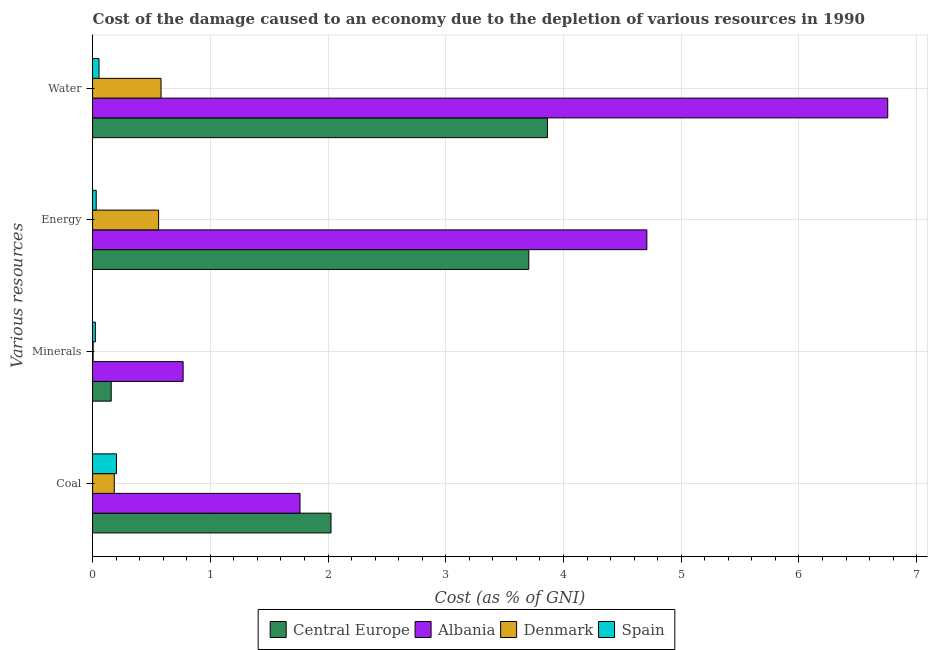How many groups of bars are there?
Give a very brief answer. 4. Are the number of bars per tick equal to the number of legend labels?
Offer a very short reply. Yes. Are the number of bars on each tick of the Y-axis equal?
Give a very brief answer. Yes. How many bars are there on the 3rd tick from the top?
Give a very brief answer. 4. How many bars are there on the 2nd tick from the bottom?
Make the answer very short. 4. What is the label of the 2nd group of bars from the top?
Offer a very short reply. Energy. What is the cost of damage due to depletion of minerals in Denmark?
Offer a very short reply. 0. Across all countries, what is the maximum cost of damage due to depletion of water?
Provide a succinct answer. 6.75. Across all countries, what is the minimum cost of damage due to depletion of energy?
Ensure brevity in your answer.  0.03. In which country was the cost of damage due to depletion of energy maximum?
Make the answer very short. Albania. In which country was the cost of damage due to depletion of coal minimum?
Offer a very short reply. Denmark. What is the total cost of damage due to depletion of water in the graph?
Your answer should be compact. 11.25. What is the difference between the cost of damage due to depletion of water in Spain and that in Denmark?
Provide a short and direct response. -0.53. What is the difference between the cost of damage due to depletion of coal in Central Europe and the cost of damage due to depletion of water in Denmark?
Ensure brevity in your answer.  1.44. What is the average cost of damage due to depletion of coal per country?
Keep it short and to the point. 1.04. What is the difference between the cost of damage due to depletion of coal and cost of damage due to depletion of minerals in Albania?
Provide a succinct answer. 0.99. What is the ratio of the cost of damage due to depletion of water in Spain to that in Denmark?
Provide a succinct answer. 0.09. Is the difference between the cost of damage due to depletion of minerals in Spain and Denmark greater than the difference between the cost of damage due to depletion of water in Spain and Denmark?
Provide a succinct answer. Yes. What is the difference between the highest and the second highest cost of damage due to depletion of water?
Your answer should be compact. 2.89. What is the difference between the highest and the lowest cost of damage due to depletion of water?
Your response must be concise. 6.7. In how many countries, is the cost of damage due to depletion of minerals greater than the average cost of damage due to depletion of minerals taken over all countries?
Your answer should be very brief. 1. What does the 4th bar from the top in Coal represents?
Provide a succinct answer. Central Europe. Is it the case that in every country, the sum of the cost of damage due to depletion of coal and cost of damage due to depletion of minerals is greater than the cost of damage due to depletion of energy?
Ensure brevity in your answer.  No. How many bars are there?
Give a very brief answer. 16. Are all the bars in the graph horizontal?
Your answer should be very brief. Yes. How many countries are there in the graph?
Give a very brief answer. 4. What is the difference between two consecutive major ticks on the X-axis?
Your response must be concise. 1. Are the values on the major ticks of X-axis written in scientific E-notation?
Your answer should be very brief. No. Does the graph contain any zero values?
Your response must be concise. No. Does the graph contain grids?
Give a very brief answer. Yes. How many legend labels are there?
Offer a terse response. 4. How are the legend labels stacked?
Offer a terse response. Horizontal. What is the title of the graph?
Your answer should be compact. Cost of the damage caused to an economy due to the depletion of various resources in 1990 . Does "Latvia" appear as one of the legend labels in the graph?
Ensure brevity in your answer.  No. What is the label or title of the X-axis?
Ensure brevity in your answer.  Cost (as % of GNI). What is the label or title of the Y-axis?
Keep it short and to the point. Various resources. What is the Cost (as % of GNI) in Central Europe in Coal?
Your response must be concise. 2.03. What is the Cost (as % of GNI) of Albania in Coal?
Ensure brevity in your answer.  1.76. What is the Cost (as % of GNI) of Denmark in Coal?
Give a very brief answer. 0.18. What is the Cost (as % of GNI) in Spain in Coal?
Your response must be concise. 0.2. What is the Cost (as % of GNI) of Central Europe in Minerals?
Your response must be concise. 0.16. What is the Cost (as % of GNI) of Albania in Minerals?
Provide a short and direct response. 0.77. What is the Cost (as % of GNI) of Denmark in Minerals?
Provide a short and direct response. 0. What is the Cost (as % of GNI) of Spain in Minerals?
Provide a short and direct response. 0.02. What is the Cost (as % of GNI) in Central Europe in Energy?
Provide a short and direct response. 3.71. What is the Cost (as % of GNI) in Albania in Energy?
Ensure brevity in your answer.  4.71. What is the Cost (as % of GNI) in Denmark in Energy?
Make the answer very short. 0.56. What is the Cost (as % of GNI) in Spain in Energy?
Your answer should be compact. 0.03. What is the Cost (as % of GNI) of Central Europe in Water?
Provide a succinct answer. 3.86. What is the Cost (as % of GNI) of Albania in Water?
Offer a very short reply. 6.75. What is the Cost (as % of GNI) of Denmark in Water?
Keep it short and to the point. 0.58. What is the Cost (as % of GNI) of Spain in Water?
Your answer should be very brief. 0.05. Across all Various resources, what is the maximum Cost (as % of GNI) of Central Europe?
Keep it short and to the point. 3.86. Across all Various resources, what is the maximum Cost (as % of GNI) of Albania?
Offer a terse response. 6.75. Across all Various resources, what is the maximum Cost (as % of GNI) of Denmark?
Provide a succinct answer. 0.58. Across all Various resources, what is the maximum Cost (as % of GNI) of Spain?
Give a very brief answer. 0.2. Across all Various resources, what is the minimum Cost (as % of GNI) in Central Europe?
Your answer should be very brief. 0.16. Across all Various resources, what is the minimum Cost (as % of GNI) of Albania?
Make the answer very short. 0.77. Across all Various resources, what is the minimum Cost (as % of GNI) in Denmark?
Provide a short and direct response. 0. Across all Various resources, what is the minimum Cost (as % of GNI) of Spain?
Provide a short and direct response. 0.02. What is the total Cost (as % of GNI) of Central Europe in the graph?
Your answer should be very brief. 9.75. What is the total Cost (as % of GNI) in Albania in the graph?
Provide a short and direct response. 13.99. What is the total Cost (as % of GNI) of Denmark in the graph?
Provide a short and direct response. 1.33. What is the total Cost (as % of GNI) in Spain in the graph?
Provide a short and direct response. 0.31. What is the difference between the Cost (as % of GNI) in Central Europe in Coal and that in Minerals?
Offer a very short reply. 1.87. What is the difference between the Cost (as % of GNI) in Denmark in Coal and that in Minerals?
Your answer should be compact. 0.18. What is the difference between the Cost (as % of GNI) in Spain in Coal and that in Minerals?
Your answer should be very brief. 0.18. What is the difference between the Cost (as % of GNI) in Central Europe in Coal and that in Energy?
Your answer should be very brief. -1.68. What is the difference between the Cost (as % of GNI) of Albania in Coal and that in Energy?
Make the answer very short. -2.95. What is the difference between the Cost (as % of GNI) of Denmark in Coal and that in Energy?
Keep it short and to the point. -0.38. What is the difference between the Cost (as % of GNI) of Spain in Coal and that in Energy?
Keep it short and to the point. 0.17. What is the difference between the Cost (as % of GNI) in Central Europe in Coal and that in Water?
Provide a succinct answer. -1.84. What is the difference between the Cost (as % of GNI) in Albania in Coal and that in Water?
Your response must be concise. -4.99. What is the difference between the Cost (as % of GNI) of Denmark in Coal and that in Water?
Keep it short and to the point. -0.4. What is the difference between the Cost (as % of GNI) of Spain in Coal and that in Water?
Your response must be concise. 0.15. What is the difference between the Cost (as % of GNI) in Central Europe in Minerals and that in Energy?
Your response must be concise. -3.55. What is the difference between the Cost (as % of GNI) in Albania in Minerals and that in Energy?
Provide a succinct answer. -3.94. What is the difference between the Cost (as % of GNI) of Denmark in Minerals and that in Energy?
Your answer should be compact. -0.56. What is the difference between the Cost (as % of GNI) of Spain in Minerals and that in Energy?
Offer a terse response. -0.01. What is the difference between the Cost (as % of GNI) in Central Europe in Minerals and that in Water?
Your answer should be very brief. -3.71. What is the difference between the Cost (as % of GNI) in Albania in Minerals and that in Water?
Your response must be concise. -5.99. What is the difference between the Cost (as % of GNI) in Denmark in Minerals and that in Water?
Offer a terse response. -0.58. What is the difference between the Cost (as % of GNI) of Spain in Minerals and that in Water?
Provide a succinct answer. -0.03. What is the difference between the Cost (as % of GNI) in Central Europe in Energy and that in Water?
Ensure brevity in your answer.  -0.16. What is the difference between the Cost (as % of GNI) in Albania in Energy and that in Water?
Make the answer very short. -2.05. What is the difference between the Cost (as % of GNI) of Denmark in Energy and that in Water?
Your answer should be very brief. -0.02. What is the difference between the Cost (as % of GNI) of Spain in Energy and that in Water?
Offer a very short reply. -0.02. What is the difference between the Cost (as % of GNI) of Central Europe in Coal and the Cost (as % of GNI) of Albania in Minerals?
Your answer should be compact. 1.26. What is the difference between the Cost (as % of GNI) of Central Europe in Coal and the Cost (as % of GNI) of Denmark in Minerals?
Provide a short and direct response. 2.02. What is the difference between the Cost (as % of GNI) in Central Europe in Coal and the Cost (as % of GNI) in Spain in Minerals?
Give a very brief answer. 2. What is the difference between the Cost (as % of GNI) of Albania in Coal and the Cost (as % of GNI) of Denmark in Minerals?
Ensure brevity in your answer.  1.76. What is the difference between the Cost (as % of GNI) of Albania in Coal and the Cost (as % of GNI) of Spain in Minerals?
Offer a terse response. 1.74. What is the difference between the Cost (as % of GNI) of Denmark in Coal and the Cost (as % of GNI) of Spain in Minerals?
Provide a succinct answer. 0.16. What is the difference between the Cost (as % of GNI) of Central Europe in Coal and the Cost (as % of GNI) of Albania in Energy?
Give a very brief answer. -2.68. What is the difference between the Cost (as % of GNI) of Central Europe in Coal and the Cost (as % of GNI) of Denmark in Energy?
Offer a very short reply. 1.46. What is the difference between the Cost (as % of GNI) in Central Europe in Coal and the Cost (as % of GNI) in Spain in Energy?
Your response must be concise. 1.99. What is the difference between the Cost (as % of GNI) of Albania in Coal and the Cost (as % of GNI) of Denmark in Energy?
Give a very brief answer. 1.2. What is the difference between the Cost (as % of GNI) of Albania in Coal and the Cost (as % of GNI) of Spain in Energy?
Ensure brevity in your answer.  1.73. What is the difference between the Cost (as % of GNI) of Denmark in Coal and the Cost (as % of GNI) of Spain in Energy?
Ensure brevity in your answer.  0.15. What is the difference between the Cost (as % of GNI) of Central Europe in Coal and the Cost (as % of GNI) of Albania in Water?
Your answer should be compact. -4.73. What is the difference between the Cost (as % of GNI) of Central Europe in Coal and the Cost (as % of GNI) of Denmark in Water?
Make the answer very short. 1.44. What is the difference between the Cost (as % of GNI) in Central Europe in Coal and the Cost (as % of GNI) in Spain in Water?
Offer a terse response. 1.97. What is the difference between the Cost (as % of GNI) of Albania in Coal and the Cost (as % of GNI) of Denmark in Water?
Your answer should be very brief. 1.18. What is the difference between the Cost (as % of GNI) of Albania in Coal and the Cost (as % of GNI) of Spain in Water?
Ensure brevity in your answer.  1.71. What is the difference between the Cost (as % of GNI) in Denmark in Coal and the Cost (as % of GNI) in Spain in Water?
Keep it short and to the point. 0.13. What is the difference between the Cost (as % of GNI) in Central Europe in Minerals and the Cost (as % of GNI) in Albania in Energy?
Give a very brief answer. -4.55. What is the difference between the Cost (as % of GNI) in Central Europe in Minerals and the Cost (as % of GNI) in Denmark in Energy?
Make the answer very short. -0.4. What is the difference between the Cost (as % of GNI) of Central Europe in Minerals and the Cost (as % of GNI) of Spain in Energy?
Keep it short and to the point. 0.13. What is the difference between the Cost (as % of GNI) in Albania in Minerals and the Cost (as % of GNI) in Denmark in Energy?
Keep it short and to the point. 0.21. What is the difference between the Cost (as % of GNI) of Albania in Minerals and the Cost (as % of GNI) of Spain in Energy?
Keep it short and to the point. 0.74. What is the difference between the Cost (as % of GNI) in Denmark in Minerals and the Cost (as % of GNI) in Spain in Energy?
Ensure brevity in your answer.  -0.03. What is the difference between the Cost (as % of GNI) in Central Europe in Minerals and the Cost (as % of GNI) in Albania in Water?
Your response must be concise. -6.6. What is the difference between the Cost (as % of GNI) in Central Europe in Minerals and the Cost (as % of GNI) in Denmark in Water?
Provide a succinct answer. -0.42. What is the difference between the Cost (as % of GNI) of Central Europe in Minerals and the Cost (as % of GNI) of Spain in Water?
Give a very brief answer. 0.1. What is the difference between the Cost (as % of GNI) in Albania in Minerals and the Cost (as % of GNI) in Denmark in Water?
Your answer should be very brief. 0.19. What is the difference between the Cost (as % of GNI) of Albania in Minerals and the Cost (as % of GNI) of Spain in Water?
Give a very brief answer. 0.71. What is the difference between the Cost (as % of GNI) of Denmark in Minerals and the Cost (as % of GNI) of Spain in Water?
Make the answer very short. -0.05. What is the difference between the Cost (as % of GNI) of Central Europe in Energy and the Cost (as % of GNI) of Albania in Water?
Give a very brief answer. -3.05. What is the difference between the Cost (as % of GNI) of Central Europe in Energy and the Cost (as % of GNI) of Denmark in Water?
Your answer should be very brief. 3.12. What is the difference between the Cost (as % of GNI) of Central Europe in Energy and the Cost (as % of GNI) of Spain in Water?
Your answer should be compact. 3.65. What is the difference between the Cost (as % of GNI) of Albania in Energy and the Cost (as % of GNI) of Denmark in Water?
Your answer should be compact. 4.13. What is the difference between the Cost (as % of GNI) of Albania in Energy and the Cost (as % of GNI) of Spain in Water?
Offer a terse response. 4.65. What is the difference between the Cost (as % of GNI) of Denmark in Energy and the Cost (as % of GNI) of Spain in Water?
Your response must be concise. 0.51. What is the average Cost (as % of GNI) in Central Europe per Various resources?
Provide a short and direct response. 2.44. What is the average Cost (as % of GNI) in Albania per Various resources?
Your response must be concise. 3.5. What is the average Cost (as % of GNI) in Denmark per Various resources?
Your answer should be compact. 0.33. What is the average Cost (as % of GNI) of Spain per Various resources?
Your response must be concise. 0.08. What is the difference between the Cost (as % of GNI) in Central Europe and Cost (as % of GNI) in Albania in Coal?
Your answer should be compact. 0.26. What is the difference between the Cost (as % of GNI) of Central Europe and Cost (as % of GNI) of Denmark in Coal?
Your response must be concise. 1.84. What is the difference between the Cost (as % of GNI) of Central Europe and Cost (as % of GNI) of Spain in Coal?
Make the answer very short. 1.82. What is the difference between the Cost (as % of GNI) of Albania and Cost (as % of GNI) of Denmark in Coal?
Give a very brief answer. 1.58. What is the difference between the Cost (as % of GNI) in Albania and Cost (as % of GNI) in Spain in Coal?
Offer a terse response. 1.56. What is the difference between the Cost (as % of GNI) in Denmark and Cost (as % of GNI) in Spain in Coal?
Your answer should be compact. -0.02. What is the difference between the Cost (as % of GNI) of Central Europe and Cost (as % of GNI) of Albania in Minerals?
Your answer should be very brief. -0.61. What is the difference between the Cost (as % of GNI) in Central Europe and Cost (as % of GNI) in Denmark in Minerals?
Give a very brief answer. 0.15. What is the difference between the Cost (as % of GNI) of Central Europe and Cost (as % of GNI) of Spain in Minerals?
Make the answer very short. 0.13. What is the difference between the Cost (as % of GNI) of Albania and Cost (as % of GNI) of Denmark in Minerals?
Give a very brief answer. 0.76. What is the difference between the Cost (as % of GNI) of Albania and Cost (as % of GNI) of Spain in Minerals?
Make the answer very short. 0.75. What is the difference between the Cost (as % of GNI) of Denmark and Cost (as % of GNI) of Spain in Minerals?
Make the answer very short. -0.02. What is the difference between the Cost (as % of GNI) of Central Europe and Cost (as % of GNI) of Albania in Energy?
Your answer should be very brief. -1. What is the difference between the Cost (as % of GNI) of Central Europe and Cost (as % of GNI) of Denmark in Energy?
Provide a succinct answer. 3.14. What is the difference between the Cost (as % of GNI) in Central Europe and Cost (as % of GNI) in Spain in Energy?
Provide a succinct answer. 3.67. What is the difference between the Cost (as % of GNI) in Albania and Cost (as % of GNI) in Denmark in Energy?
Give a very brief answer. 4.15. What is the difference between the Cost (as % of GNI) in Albania and Cost (as % of GNI) in Spain in Energy?
Your answer should be very brief. 4.68. What is the difference between the Cost (as % of GNI) of Denmark and Cost (as % of GNI) of Spain in Energy?
Offer a very short reply. 0.53. What is the difference between the Cost (as % of GNI) in Central Europe and Cost (as % of GNI) in Albania in Water?
Offer a terse response. -2.89. What is the difference between the Cost (as % of GNI) in Central Europe and Cost (as % of GNI) in Denmark in Water?
Offer a terse response. 3.28. What is the difference between the Cost (as % of GNI) in Central Europe and Cost (as % of GNI) in Spain in Water?
Give a very brief answer. 3.81. What is the difference between the Cost (as % of GNI) in Albania and Cost (as % of GNI) in Denmark in Water?
Provide a succinct answer. 6.17. What is the difference between the Cost (as % of GNI) of Albania and Cost (as % of GNI) of Spain in Water?
Provide a short and direct response. 6.7. What is the difference between the Cost (as % of GNI) of Denmark and Cost (as % of GNI) of Spain in Water?
Provide a succinct answer. 0.53. What is the ratio of the Cost (as % of GNI) of Central Europe in Coal to that in Minerals?
Your answer should be compact. 12.8. What is the ratio of the Cost (as % of GNI) in Albania in Coal to that in Minerals?
Offer a terse response. 2.29. What is the ratio of the Cost (as % of GNI) in Denmark in Coal to that in Minerals?
Provide a short and direct response. 37.96. What is the ratio of the Cost (as % of GNI) of Spain in Coal to that in Minerals?
Offer a terse response. 8.54. What is the ratio of the Cost (as % of GNI) in Central Europe in Coal to that in Energy?
Your response must be concise. 0.55. What is the ratio of the Cost (as % of GNI) in Albania in Coal to that in Energy?
Provide a succinct answer. 0.37. What is the ratio of the Cost (as % of GNI) in Denmark in Coal to that in Energy?
Provide a succinct answer. 0.33. What is the ratio of the Cost (as % of GNI) in Spain in Coal to that in Energy?
Make the answer very short. 6.55. What is the ratio of the Cost (as % of GNI) of Central Europe in Coal to that in Water?
Ensure brevity in your answer.  0.52. What is the ratio of the Cost (as % of GNI) of Albania in Coal to that in Water?
Provide a succinct answer. 0.26. What is the ratio of the Cost (as % of GNI) of Denmark in Coal to that in Water?
Your answer should be very brief. 0.32. What is the ratio of the Cost (as % of GNI) in Spain in Coal to that in Water?
Your answer should be very brief. 3.71. What is the ratio of the Cost (as % of GNI) in Central Europe in Minerals to that in Energy?
Your answer should be very brief. 0.04. What is the ratio of the Cost (as % of GNI) of Albania in Minerals to that in Energy?
Make the answer very short. 0.16. What is the ratio of the Cost (as % of GNI) of Denmark in Minerals to that in Energy?
Your response must be concise. 0.01. What is the ratio of the Cost (as % of GNI) of Spain in Minerals to that in Energy?
Your answer should be very brief. 0.77. What is the ratio of the Cost (as % of GNI) of Central Europe in Minerals to that in Water?
Your answer should be very brief. 0.04. What is the ratio of the Cost (as % of GNI) of Albania in Minerals to that in Water?
Ensure brevity in your answer.  0.11. What is the ratio of the Cost (as % of GNI) of Denmark in Minerals to that in Water?
Keep it short and to the point. 0.01. What is the ratio of the Cost (as % of GNI) in Spain in Minerals to that in Water?
Your answer should be compact. 0.43. What is the ratio of the Cost (as % of GNI) of Albania in Energy to that in Water?
Give a very brief answer. 0.7. What is the ratio of the Cost (as % of GNI) in Denmark in Energy to that in Water?
Make the answer very short. 0.96. What is the ratio of the Cost (as % of GNI) of Spain in Energy to that in Water?
Your answer should be very brief. 0.57. What is the difference between the highest and the second highest Cost (as % of GNI) in Central Europe?
Your answer should be very brief. 0.16. What is the difference between the highest and the second highest Cost (as % of GNI) in Albania?
Offer a terse response. 2.05. What is the difference between the highest and the second highest Cost (as % of GNI) in Denmark?
Offer a very short reply. 0.02. What is the difference between the highest and the second highest Cost (as % of GNI) in Spain?
Keep it short and to the point. 0.15. What is the difference between the highest and the lowest Cost (as % of GNI) of Central Europe?
Provide a succinct answer. 3.71. What is the difference between the highest and the lowest Cost (as % of GNI) of Albania?
Keep it short and to the point. 5.99. What is the difference between the highest and the lowest Cost (as % of GNI) of Denmark?
Offer a very short reply. 0.58. What is the difference between the highest and the lowest Cost (as % of GNI) of Spain?
Your answer should be very brief. 0.18. 